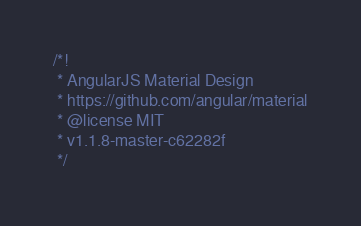Convert code to text. <code><loc_0><loc_0><loc_500><loc_500><_JavaScript_>/*!
 * AngularJS Material Design
 * https://github.com/angular/material
 * @license MIT
 * v1.1.8-master-c62282f
 */</code> 